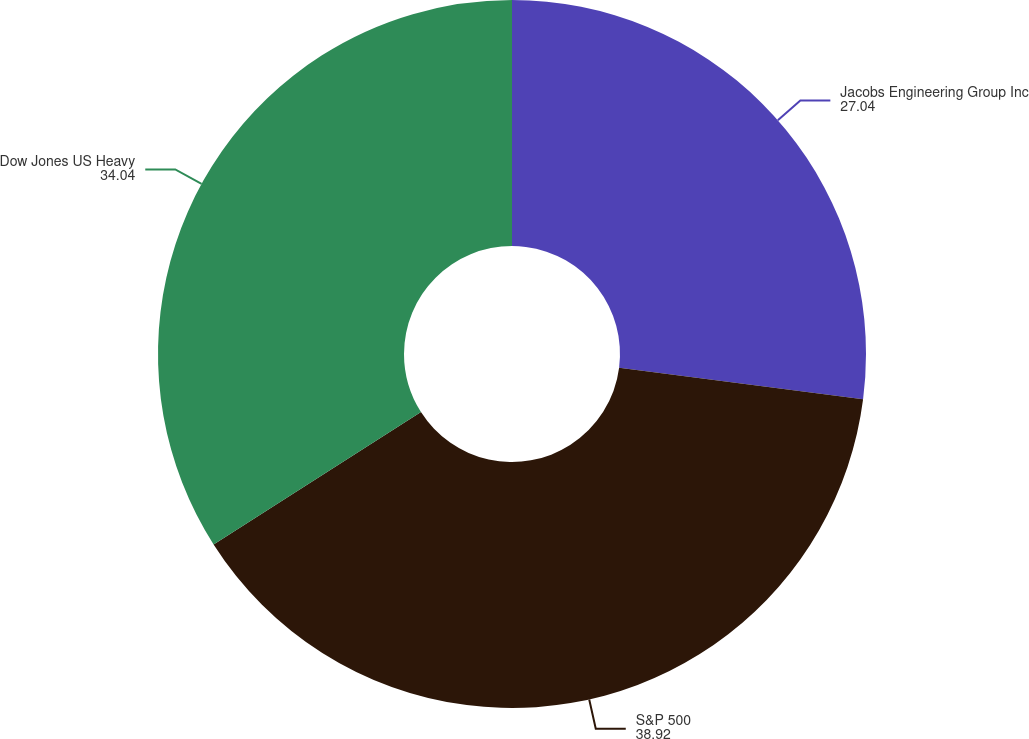<chart> <loc_0><loc_0><loc_500><loc_500><pie_chart><fcel>Jacobs Engineering Group Inc<fcel>S&P 500<fcel>Dow Jones US Heavy<nl><fcel>27.04%<fcel>38.92%<fcel>34.04%<nl></chart> 